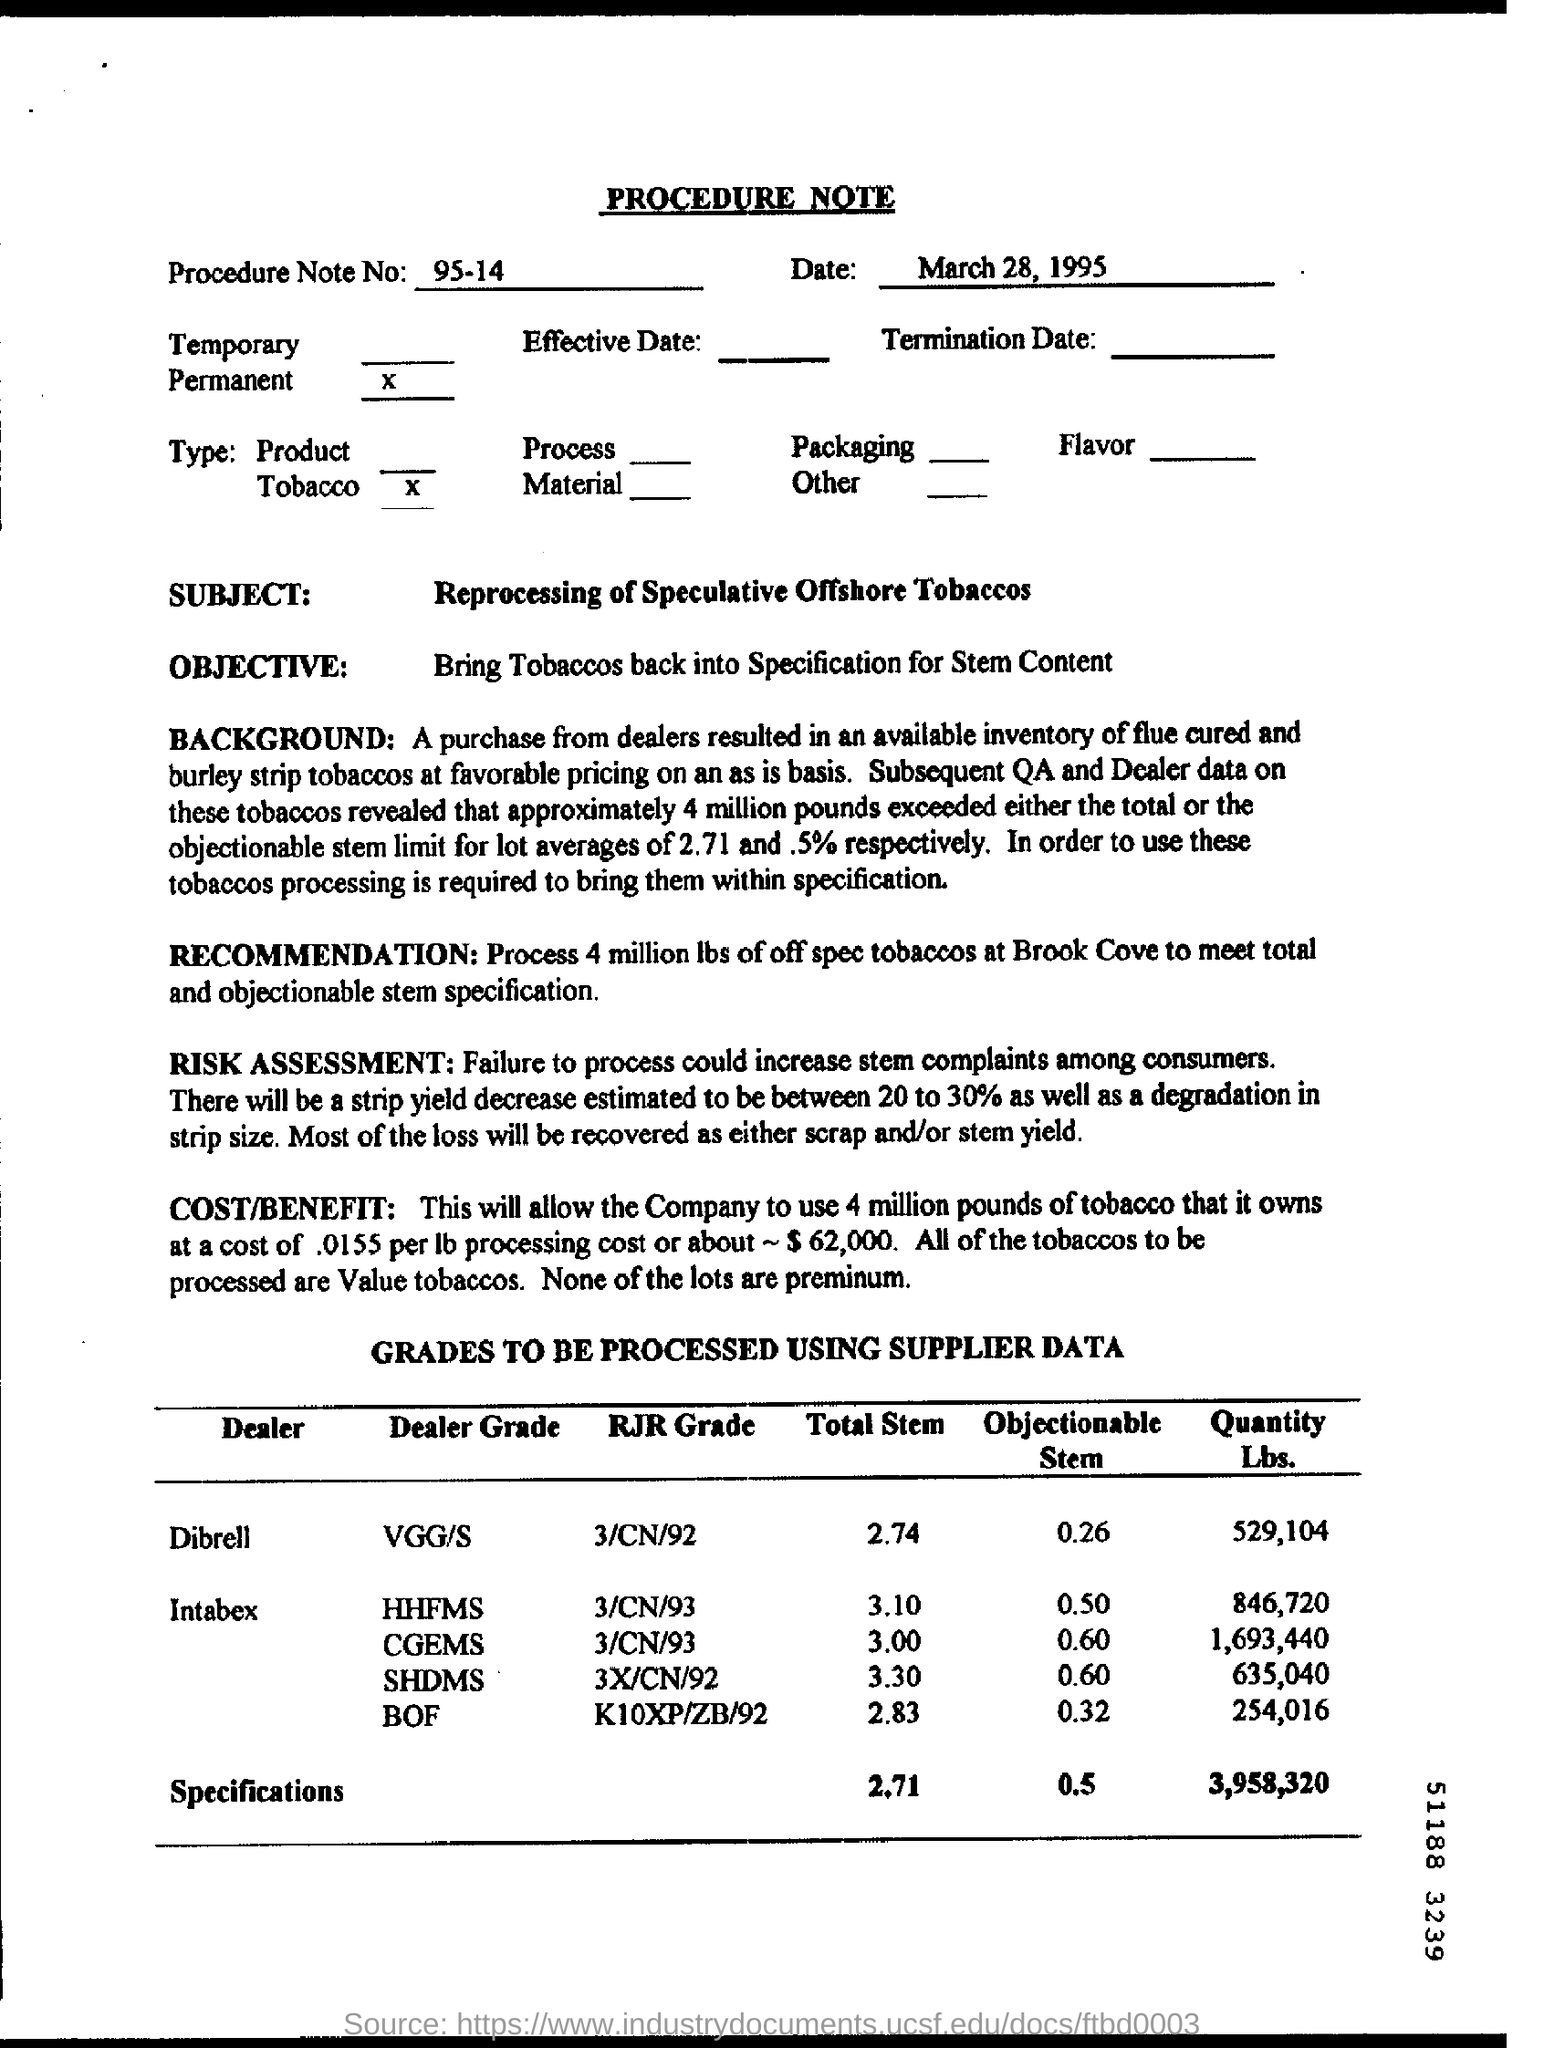What cost-benefit analysis is provided in the note? The cost-benefit analysis indicates that processing the 4 million pounds of tobacco will cost approximately $62,000 at a processing cost of about 0.0155 per pound. The note clarifies that all of the tobaccos to be processed are considered value tobaccos, not premium. 